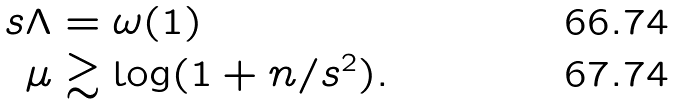Convert formula to latex. <formula><loc_0><loc_0><loc_500><loc_500>s \Lambda & = \omega ( 1 ) \\ \mu & \gtrsim \log ( 1 + n / s ^ { 2 } ) .</formula> 